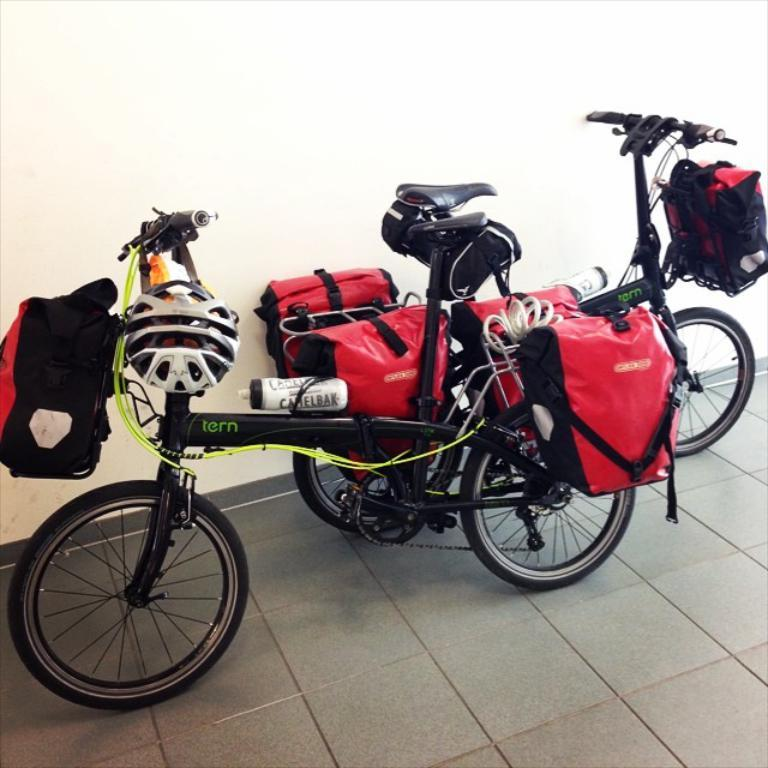What type of vehicles are in the image? There are bicycles in the image. Where are the bicycles located in relation to other objects? The bicycles are near a wall. What items are attached to the bicycles? There are bags and helmets attached to the bicycles. What color is the crayon used to draw on the wall in the image? There is no crayon or drawing on the wall in the image. What type of pan is being used to cook on the bicycles in the image? There are no pans or cooking activities depicted in the image; it features bicycles with bags and helmets attached. 